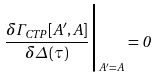Convert formula to latex. <formula><loc_0><loc_0><loc_500><loc_500>\frac { \delta \Gamma _ { C T P } \left [ A ^ { \prime } , A \right ] } { \delta \Delta \left ( \tau \right ) } \Big | _ { A ^ { \prime } = A } = 0</formula> 